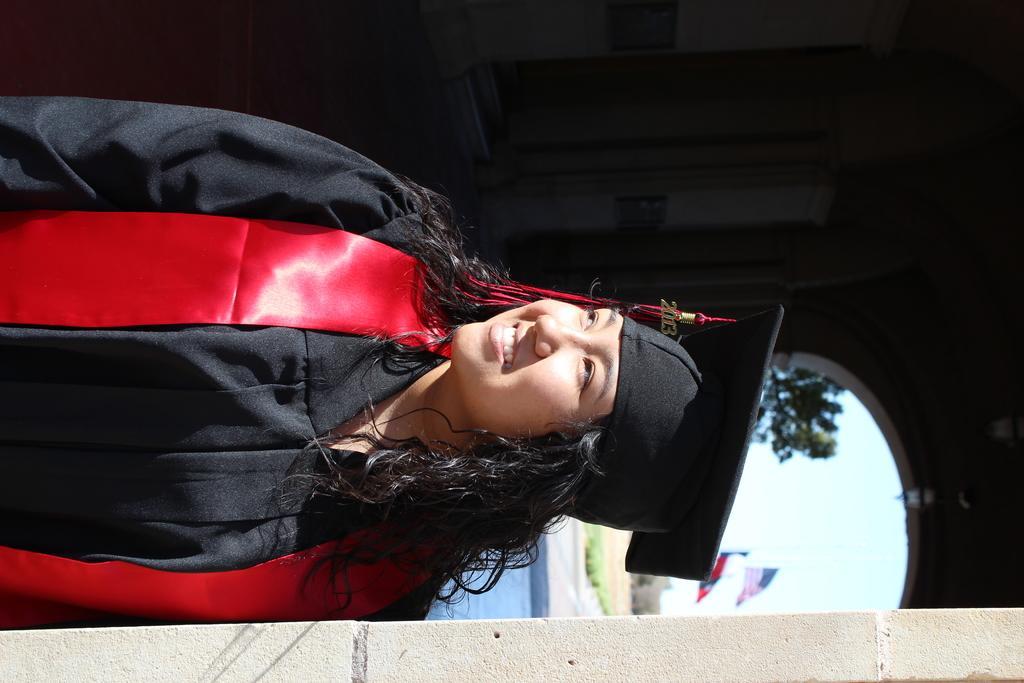Could you give a brief overview of what you see in this image? In this image in the center there is a woman standing and smiling. In the background there is a tree and there are flags and there's grass on the ground. 